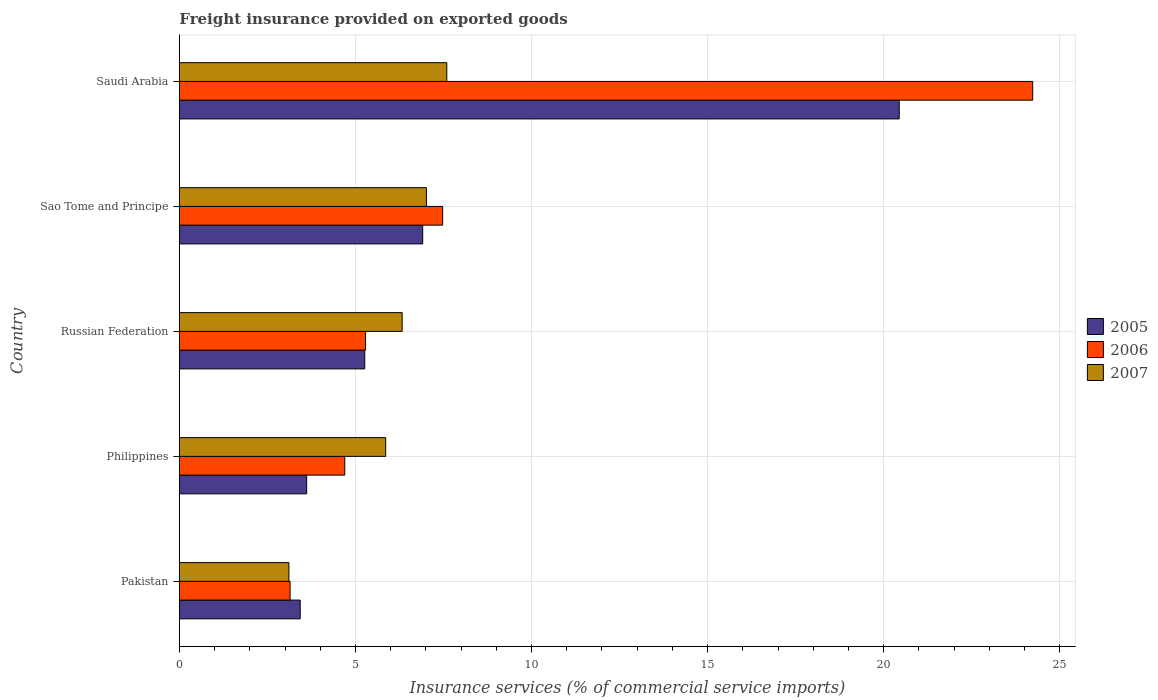How many bars are there on the 3rd tick from the top?
Offer a very short reply. 3. What is the label of the 1st group of bars from the top?
Provide a succinct answer. Saudi Arabia. What is the freight insurance provided on exported goods in 2006 in Pakistan?
Keep it short and to the point. 3.14. Across all countries, what is the maximum freight insurance provided on exported goods in 2006?
Make the answer very short. 24.23. Across all countries, what is the minimum freight insurance provided on exported goods in 2007?
Provide a short and direct response. 3.11. In which country was the freight insurance provided on exported goods in 2005 maximum?
Your answer should be compact. Saudi Arabia. What is the total freight insurance provided on exported goods in 2007 in the graph?
Your answer should be compact. 29.9. What is the difference between the freight insurance provided on exported goods in 2005 in Russian Federation and that in Sao Tome and Principe?
Your answer should be very brief. -1.65. What is the difference between the freight insurance provided on exported goods in 2007 in Philippines and the freight insurance provided on exported goods in 2006 in Pakistan?
Offer a terse response. 2.71. What is the average freight insurance provided on exported goods in 2006 per country?
Provide a short and direct response. 8.97. What is the difference between the freight insurance provided on exported goods in 2005 and freight insurance provided on exported goods in 2006 in Sao Tome and Principe?
Offer a terse response. -0.57. In how many countries, is the freight insurance provided on exported goods in 2006 greater than 14 %?
Provide a succinct answer. 1. What is the ratio of the freight insurance provided on exported goods in 2006 in Pakistan to that in Russian Federation?
Your answer should be very brief. 0.59. Is the difference between the freight insurance provided on exported goods in 2005 in Philippines and Russian Federation greater than the difference between the freight insurance provided on exported goods in 2006 in Philippines and Russian Federation?
Offer a very short reply. No. What is the difference between the highest and the second highest freight insurance provided on exported goods in 2005?
Give a very brief answer. 13.53. What is the difference between the highest and the lowest freight insurance provided on exported goods in 2007?
Offer a very short reply. 4.48. In how many countries, is the freight insurance provided on exported goods in 2007 greater than the average freight insurance provided on exported goods in 2007 taken over all countries?
Offer a terse response. 3. Is the sum of the freight insurance provided on exported goods in 2005 in Russian Federation and Saudi Arabia greater than the maximum freight insurance provided on exported goods in 2006 across all countries?
Keep it short and to the point. Yes. How many countries are there in the graph?
Ensure brevity in your answer.  5. What is the difference between two consecutive major ticks on the X-axis?
Your answer should be compact. 5. Are the values on the major ticks of X-axis written in scientific E-notation?
Give a very brief answer. No. Does the graph contain any zero values?
Ensure brevity in your answer.  No. Where does the legend appear in the graph?
Your answer should be very brief. Center right. How many legend labels are there?
Offer a terse response. 3. How are the legend labels stacked?
Keep it short and to the point. Vertical. What is the title of the graph?
Ensure brevity in your answer.  Freight insurance provided on exported goods. Does "1970" appear as one of the legend labels in the graph?
Provide a short and direct response. No. What is the label or title of the X-axis?
Your answer should be very brief. Insurance services (% of commercial service imports). What is the Insurance services (% of commercial service imports) of 2005 in Pakistan?
Provide a succinct answer. 3.43. What is the Insurance services (% of commercial service imports) of 2006 in Pakistan?
Make the answer very short. 3.14. What is the Insurance services (% of commercial service imports) of 2007 in Pakistan?
Ensure brevity in your answer.  3.11. What is the Insurance services (% of commercial service imports) of 2005 in Philippines?
Ensure brevity in your answer.  3.61. What is the Insurance services (% of commercial service imports) of 2006 in Philippines?
Keep it short and to the point. 4.7. What is the Insurance services (% of commercial service imports) of 2007 in Philippines?
Your response must be concise. 5.86. What is the Insurance services (% of commercial service imports) of 2005 in Russian Federation?
Keep it short and to the point. 5.26. What is the Insurance services (% of commercial service imports) of 2006 in Russian Federation?
Ensure brevity in your answer.  5.29. What is the Insurance services (% of commercial service imports) of 2007 in Russian Federation?
Your answer should be compact. 6.33. What is the Insurance services (% of commercial service imports) of 2005 in Sao Tome and Principe?
Keep it short and to the point. 6.91. What is the Insurance services (% of commercial service imports) in 2006 in Sao Tome and Principe?
Provide a succinct answer. 7.48. What is the Insurance services (% of commercial service imports) in 2007 in Sao Tome and Principe?
Provide a succinct answer. 7.01. What is the Insurance services (% of commercial service imports) in 2005 in Saudi Arabia?
Give a very brief answer. 20.44. What is the Insurance services (% of commercial service imports) in 2006 in Saudi Arabia?
Ensure brevity in your answer.  24.23. What is the Insurance services (% of commercial service imports) in 2007 in Saudi Arabia?
Make the answer very short. 7.59. Across all countries, what is the maximum Insurance services (% of commercial service imports) in 2005?
Provide a succinct answer. 20.44. Across all countries, what is the maximum Insurance services (% of commercial service imports) in 2006?
Your response must be concise. 24.23. Across all countries, what is the maximum Insurance services (% of commercial service imports) of 2007?
Provide a succinct answer. 7.59. Across all countries, what is the minimum Insurance services (% of commercial service imports) of 2005?
Your response must be concise. 3.43. Across all countries, what is the minimum Insurance services (% of commercial service imports) in 2006?
Ensure brevity in your answer.  3.14. Across all countries, what is the minimum Insurance services (% of commercial service imports) of 2007?
Your response must be concise. 3.11. What is the total Insurance services (% of commercial service imports) in 2005 in the graph?
Your answer should be compact. 39.66. What is the total Insurance services (% of commercial service imports) of 2006 in the graph?
Give a very brief answer. 44.83. What is the total Insurance services (% of commercial service imports) of 2007 in the graph?
Your answer should be very brief. 29.9. What is the difference between the Insurance services (% of commercial service imports) in 2005 in Pakistan and that in Philippines?
Provide a succinct answer. -0.18. What is the difference between the Insurance services (% of commercial service imports) in 2006 in Pakistan and that in Philippines?
Give a very brief answer. -1.55. What is the difference between the Insurance services (% of commercial service imports) in 2007 in Pakistan and that in Philippines?
Provide a short and direct response. -2.75. What is the difference between the Insurance services (% of commercial service imports) of 2005 in Pakistan and that in Russian Federation?
Offer a terse response. -1.83. What is the difference between the Insurance services (% of commercial service imports) in 2006 in Pakistan and that in Russian Federation?
Your answer should be very brief. -2.14. What is the difference between the Insurance services (% of commercial service imports) of 2007 in Pakistan and that in Russian Federation?
Provide a succinct answer. -3.22. What is the difference between the Insurance services (% of commercial service imports) of 2005 in Pakistan and that in Sao Tome and Principe?
Offer a terse response. -3.48. What is the difference between the Insurance services (% of commercial service imports) of 2006 in Pakistan and that in Sao Tome and Principe?
Make the answer very short. -4.33. What is the difference between the Insurance services (% of commercial service imports) of 2007 in Pakistan and that in Sao Tome and Principe?
Keep it short and to the point. -3.9. What is the difference between the Insurance services (% of commercial service imports) of 2005 in Pakistan and that in Saudi Arabia?
Your answer should be compact. -17.01. What is the difference between the Insurance services (% of commercial service imports) in 2006 in Pakistan and that in Saudi Arabia?
Keep it short and to the point. -21.09. What is the difference between the Insurance services (% of commercial service imports) of 2007 in Pakistan and that in Saudi Arabia?
Provide a succinct answer. -4.48. What is the difference between the Insurance services (% of commercial service imports) of 2005 in Philippines and that in Russian Federation?
Offer a very short reply. -1.65. What is the difference between the Insurance services (% of commercial service imports) in 2006 in Philippines and that in Russian Federation?
Your answer should be compact. -0.59. What is the difference between the Insurance services (% of commercial service imports) in 2007 in Philippines and that in Russian Federation?
Make the answer very short. -0.47. What is the difference between the Insurance services (% of commercial service imports) in 2005 in Philippines and that in Sao Tome and Principe?
Ensure brevity in your answer.  -3.3. What is the difference between the Insurance services (% of commercial service imports) of 2006 in Philippines and that in Sao Tome and Principe?
Offer a very short reply. -2.78. What is the difference between the Insurance services (% of commercial service imports) in 2007 in Philippines and that in Sao Tome and Principe?
Your answer should be compact. -1.16. What is the difference between the Insurance services (% of commercial service imports) in 2005 in Philippines and that in Saudi Arabia?
Ensure brevity in your answer.  -16.83. What is the difference between the Insurance services (% of commercial service imports) of 2006 in Philippines and that in Saudi Arabia?
Provide a succinct answer. -19.54. What is the difference between the Insurance services (% of commercial service imports) in 2007 in Philippines and that in Saudi Arabia?
Give a very brief answer. -1.74. What is the difference between the Insurance services (% of commercial service imports) of 2005 in Russian Federation and that in Sao Tome and Principe?
Your response must be concise. -1.65. What is the difference between the Insurance services (% of commercial service imports) in 2006 in Russian Federation and that in Sao Tome and Principe?
Offer a terse response. -2.19. What is the difference between the Insurance services (% of commercial service imports) of 2007 in Russian Federation and that in Sao Tome and Principe?
Give a very brief answer. -0.69. What is the difference between the Insurance services (% of commercial service imports) in 2005 in Russian Federation and that in Saudi Arabia?
Keep it short and to the point. -15.18. What is the difference between the Insurance services (% of commercial service imports) in 2006 in Russian Federation and that in Saudi Arabia?
Offer a very short reply. -18.95. What is the difference between the Insurance services (% of commercial service imports) of 2007 in Russian Federation and that in Saudi Arabia?
Make the answer very short. -1.27. What is the difference between the Insurance services (% of commercial service imports) in 2005 in Sao Tome and Principe and that in Saudi Arabia?
Make the answer very short. -13.53. What is the difference between the Insurance services (% of commercial service imports) of 2006 in Sao Tome and Principe and that in Saudi Arabia?
Provide a short and direct response. -16.76. What is the difference between the Insurance services (% of commercial service imports) in 2007 in Sao Tome and Principe and that in Saudi Arabia?
Provide a succinct answer. -0.58. What is the difference between the Insurance services (% of commercial service imports) in 2005 in Pakistan and the Insurance services (% of commercial service imports) in 2006 in Philippines?
Keep it short and to the point. -1.27. What is the difference between the Insurance services (% of commercial service imports) in 2005 in Pakistan and the Insurance services (% of commercial service imports) in 2007 in Philippines?
Keep it short and to the point. -2.43. What is the difference between the Insurance services (% of commercial service imports) of 2006 in Pakistan and the Insurance services (% of commercial service imports) of 2007 in Philippines?
Offer a terse response. -2.71. What is the difference between the Insurance services (% of commercial service imports) of 2005 in Pakistan and the Insurance services (% of commercial service imports) of 2006 in Russian Federation?
Offer a terse response. -1.85. What is the difference between the Insurance services (% of commercial service imports) of 2005 in Pakistan and the Insurance services (% of commercial service imports) of 2007 in Russian Federation?
Give a very brief answer. -2.9. What is the difference between the Insurance services (% of commercial service imports) of 2006 in Pakistan and the Insurance services (% of commercial service imports) of 2007 in Russian Federation?
Offer a terse response. -3.18. What is the difference between the Insurance services (% of commercial service imports) in 2005 in Pakistan and the Insurance services (% of commercial service imports) in 2006 in Sao Tome and Principe?
Your response must be concise. -4.04. What is the difference between the Insurance services (% of commercial service imports) in 2005 in Pakistan and the Insurance services (% of commercial service imports) in 2007 in Sao Tome and Principe?
Your answer should be very brief. -3.58. What is the difference between the Insurance services (% of commercial service imports) in 2006 in Pakistan and the Insurance services (% of commercial service imports) in 2007 in Sao Tome and Principe?
Ensure brevity in your answer.  -3.87. What is the difference between the Insurance services (% of commercial service imports) of 2005 in Pakistan and the Insurance services (% of commercial service imports) of 2006 in Saudi Arabia?
Your response must be concise. -20.8. What is the difference between the Insurance services (% of commercial service imports) of 2005 in Pakistan and the Insurance services (% of commercial service imports) of 2007 in Saudi Arabia?
Your response must be concise. -4.16. What is the difference between the Insurance services (% of commercial service imports) of 2006 in Pakistan and the Insurance services (% of commercial service imports) of 2007 in Saudi Arabia?
Give a very brief answer. -4.45. What is the difference between the Insurance services (% of commercial service imports) of 2005 in Philippines and the Insurance services (% of commercial service imports) of 2006 in Russian Federation?
Provide a short and direct response. -1.67. What is the difference between the Insurance services (% of commercial service imports) of 2005 in Philippines and the Insurance services (% of commercial service imports) of 2007 in Russian Federation?
Offer a very short reply. -2.71. What is the difference between the Insurance services (% of commercial service imports) of 2006 in Philippines and the Insurance services (% of commercial service imports) of 2007 in Russian Federation?
Give a very brief answer. -1.63. What is the difference between the Insurance services (% of commercial service imports) of 2005 in Philippines and the Insurance services (% of commercial service imports) of 2006 in Sao Tome and Principe?
Make the answer very short. -3.86. What is the difference between the Insurance services (% of commercial service imports) in 2005 in Philippines and the Insurance services (% of commercial service imports) in 2007 in Sao Tome and Principe?
Your answer should be very brief. -3.4. What is the difference between the Insurance services (% of commercial service imports) in 2006 in Philippines and the Insurance services (% of commercial service imports) in 2007 in Sao Tome and Principe?
Provide a short and direct response. -2.32. What is the difference between the Insurance services (% of commercial service imports) in 2005 in Philippines and the Insurance services (% of commercial service imports) in 2006 in Saudi Arabia?
Give a very brief answer. -20.62. What is the difference between the Insurance services (% of commercial service imports) in 2005 in Philippines and the Insurance services (% of commercial service imports) in 2007 in Saudi Arabia?
Give a very brief answer. -3.98. What is the difference between the Insurance services (% of commercial service imports) of 2006 in Philippines and the Insurance services (% of commercial service imports) of 2007 in Saudi Arabia?
Provide a succinct answer. -2.9. What is the difference between the Insurance services (% of commercial service imports) of 2005 in Russian Federation and the Insurance services (% of commercial service imports) of 2006 in Sao Tome and Principe?
Keep it short and to the point. -2.21. What is the difference between the Insurance services (% of commercial service imports) of 2005 in Russian Federation and the Insurance services (% of commercial service imports) of 2007 in Sao Tome and Principe?
Your answer should be compact. -1.75. What is the difference between the Insurance services (% of commercial service imports) of 2006 in Russian Federation and the Insurance services (% of commercial service imports) of 2007 in Sao Tome and Principe?
Keep it short and to the point. -1.73. What is the difference between the Insurance services (% of commercial service imports) in 2005 in Russian Federation and the Insurance services (% of commercial service imports) in 2006 in Saudi Arabia?
Provide a succinct answer. -18.97. What is the difference between the Insurance services (% of commercial service imports) in 2005 in Russian Federation and the Insurance services (% of commercial service imports) in 2007 in Saudi Arabia?
Give a very brief answer. -2.33. What is the difference between the Insurance services (% of commercial service imports) in 2006 in Russian Federation and the Insurance services (% of commercial service imports) in 2007 in Saudi Arabia?
Ensure brevity in your answer.  -2.31. What is the difference between the Insurance services (% of commercial service imports) of 2005 in Sao Tome and Principe and the Insurance services (% of commercial service imports) of 2006 in Saudi Arabia?
Your answer should be very brief. -17.32. What is the difference between the Insurance services (% of commercial service imports) of 2005 in Sao Tome and Principe and the Insurance services (% of commercial service imports) of 2007 in Saudi Arabia?
Your answer should be very brief. -0.68. What is the difference between the Insurance services (% of commercial service imports) in 2006 in Sao Tome and Principe and the Insurance services (% of commercial service imports) in 2007 in Saudi Arabia?
Offer a terse response. -0.12. What is the average Insurance services (% of commercial service imports) of 2005 per country?
Offer a very short reply. 7.93. What is the average Insurance services (% of commercial service imports) of 2006 per country?
Your answer should be very brief. 8.97. What is the average Insurance services (% of commercial service imports) of 2007 per country?
Give a very brief answer. 5.98. What is the difference between the Insurance services (% of commercial service imports) of 2005 and Insurance services (% of commercial service imports) of 2006 in Pakistan?
Offer a very short reply. 0.29. What is the difference between the Insurance services (% of commercial service imports) of 2005 and Insurance services (% of commercial service imports) of 2007 in Pakistan?
Keep it short and to the point. 0.32. What is the difference between the Insurance services (% of commercial service imports) of 2006 and Insurance services (% of commercial service imports) of 2007 in Pakistan?
Make the answer very short. 0.03. What is the difference between the Insurance services (% of commercial service imports) of 2005 and Insurance services (% of commercial service imports) of 2006 in Philippines?
Keep it short and to the point. -1.08. What is the difference between the Insurance services (% of commercial service imports) of 2005 and Insurance services (% of commercial service imports) of 2007 in Philippines?
Your answer should be compact. -2.24. What is the difference between the Insurance services (% of commercial service imports) in 2006 and Insurance services (% of commercial service imports) in 2007 in Philippines?
Make the answer very short. -1.16. What is the difference between the Insurance services (% of commercial service imports) of 2005 and Insurance services (% of commercial service imports) of 2006 in Russian Federation?
Your answer should be compact. -0.02. What is the difference between the Insurance services (% of commercial service imports) in 2005 and Insurance services (% of commercial service imports) in 2007 in Russian Federation?
Offer a very short reply. -1.06. What is the difference between the Insurance services (% of commercial service imports) in 2006 and Insurance services (% of commercial service imports) in 2007 in Russian Federation?
Keep it short and to the point. -1.04. What is the difference between the Insurance services (% of commercial service imports) in 2005 and Insurance services (% of commercial service imports) in 2006 in Sao Tome and Principe?
Provide a short and direct response. -0.57. What is the difference between the Insurance services (% of commercial service imports) in 2005 and Insurance services (% of commercial service imports) in 2007 in Sao Tome and Principe?
Offer a very short reply. -0.11. What is the difference between the Insurance services (% of commercial service imports) of 2006 and Insurance services (% of commercial service imports) of 2007 in Sao Tome and Principe?
Your answer should be compact. 0.46. What is the difference between the Insurance services (% of commercial service imports) in 2005 and Insurance services (% of commercial service imports) in 2006 in Saudi Arabia?
Make the answer very short. -3.79. What is the difference between the Insurance services (% of commercial service imports) of 2005 and Insurance services (% of commercial service imports) of 2007 in Saudi Arabia?
Provide a short and direct response. 12.85. What is the difference between the Insurance services (% of commercial service imports) of 2006 and Insurance services (% of commercial service imports) of 2007 in Saudi Arabia?
Provide a short and direct response. 16.64. What is the ratio of the Insurance services (% of commercial service imports) in 2005 in Pakistan to that in Philippines?
Offer a terse response. 0.95. What is the ratio of the Insurance services (% of commercial service imports) in 2006 in Pakistan to that in Philippines?
Your answer should be very brief. 0.67. What is the ratio of the Insurance services (% of commercial service imports) of 2007 in Pakistan to that in Philippines?
Offer a terse response. 0.53. What is the ratio of the Insurance services (% of commercial service imports) of 2005 in Pakistan to that in Russian Federation?
Your answer should be very brief. 0.65. What is the ratio of the Insurance services (% of commercial service imports) of 2006 in Pakistan to that in Russian Federation?
Make the answer very short. 0.59. What is the ratio of the Insurance services (% of commercial service imports) in 2007 in Pakistan to that in Russian Federation?
Your response must be concise. 0.49. What is the ratio of the Insurance services (% of commercial service imports) of 2005 in Pakistan to that in Sao Tome and Principe?
Your answer should be compact. 0.5. What is the ratio of the Insurance services (% of commercial service imports) in 2006 in Pakistan to that in Sao Tome and Principe?
Keep it short and to the point. 0.42. What is the ratio of the Insurance services (% of commercial service imports) in 2007 in Pakistan to that in Sao Tome and Principe?
Keep it short and to the point. 0.44. What is the ratio of the Insurance services (% of commercial service imports) in 2005 in Pakistan to that in Saudi Arabia?
Make the answer very short. 0.17. What is the ratio of the Insurance services (% of commercial service imports) of 2006 in Pakistan to that in Saudi Arabia?
Offer a terse response. 0.13. What is the ratio of the Insurance services (% of commercial service imports) of 2007 in Pakistan to that in Saudi Arabia?
Offer a terse response. 0.41. What is the ratio of the Insurance services (% of commercial service imports) in 2005 in Philippines to that in Russian Federation?
Provide a succinct answer. 0.69. What is the ratio of the Insurance services (% of commercial service imports) in 2006 in Philippines to that in Russian Federation?
Offer a very short reply. 0.89. What is the ratio of the Insurance services (% of commercial service imports) of 2007 in Philippines to that in Russian Federation?
Your response must be concise. 0.93. What is the ratio of the Insurance services (% of commercial service imports) of 2005 in Philippines to that in Sao Tome and Principe?
Provide a short and direct response. 0.52. What is the ratio of the Insurance services (% of commercial service imports) of 2006 in Philippines to that in Sao Tome and Principe?
Make the answer very short. 0.63. What is the ratio of the Insurance services (% of commercial service imports) of 2007 in Philippines to that in Sao Tome and Principe?
Offer a terse response. 0.84. What is the ratio of the Insurance services (% of commercial service imports) in 2005 in Philippines to that in Saudi Arabia?
Ensure brevity in your answer.  0.18. What is the ratio of the Insurance services (% of commercial service imports) in 2006 in Philippines to that in Saudi Arabia?
Give a very brief answer. 0.19. What is the ratio of the Insurance services (% of commercial service imports) of 2007 in Philippines to that in Saudi Arabia?
Provide a short and direct response. 0.77. What is the ratio of the Insurance services (% of commercial service imports) in 2005 in Russian Federation to that in Sao Tome and Principe?
Offer a very short reply. 0.76. What is the ratio of the Insurance services (% of commercial service imports) of 2006 in Russian Federation to that in Sao Tome and Principe?
Offer a very short reply. 0.71. What is the ratio of the Insurance services (% of commercial service imports) in 2007 in Russian Federation to that in Sao Tome and Principe?
Your answer should be compact. 0.9. What is the ratio of the Insurance services (% of commercial service imports) of 2005 in Russian Federation to that in Saudi Arabia?
Your answer should be compact. 0.26. What is the ratio of the Insurance services (% of commercial service imports) in 2006 in Russian Federation to that in Saudi Arabia?
Your response must be concise. 0.22. What is the ratio of the Insurance services (% of commercial service imports) in 2007 in Russian Federation to that in Saudi Arabia?
Your answer should be very brief. 0.83. What is the ratio of the Insurance services (% of commercial service imports) of 2005 in Sao Tome and Principe to that in Saudi Arabia?
Your response must be concise. 0.34. What is the ratio of the Insurance services (% of commercial service imports) in 2006 in Sao Tome and Principe to that in Saudi Arabia?
Make the answer very short. 0.31. What is the ratio of the Insurance services (% of commercial service imports) of 2007 in Sao Tome and Principe to that in Saudi Arabia?
Offer a terse response. 0.92. What is the difference between the highest and the second highest Insurance services (% of commercial service imports) in 2005?
Offer a terse response. 13.53. What is the difference between the highest and the second highest Insurance services (% of commercial service imports) in 2006?
Make the answer very short. 16.76. What is the difference between the highest and the second highest Insurance services (% of commercial service imports) of 2007?
Your answer should be very brief. 0.58. What is the difference between the highest and the lowest Insurance services (% of commercial service imports) of 2005?
Keep it short and to the point. 17.01. What is the difference between the highest and the lowest Insurance services (% of commercial service imports) of 2006?
Offer a terse response. 21.09. What is the difference between the highest and the lowest Insurance services (% of commercial service imports) of 2007?
Your answer should be compact. 4.48. 